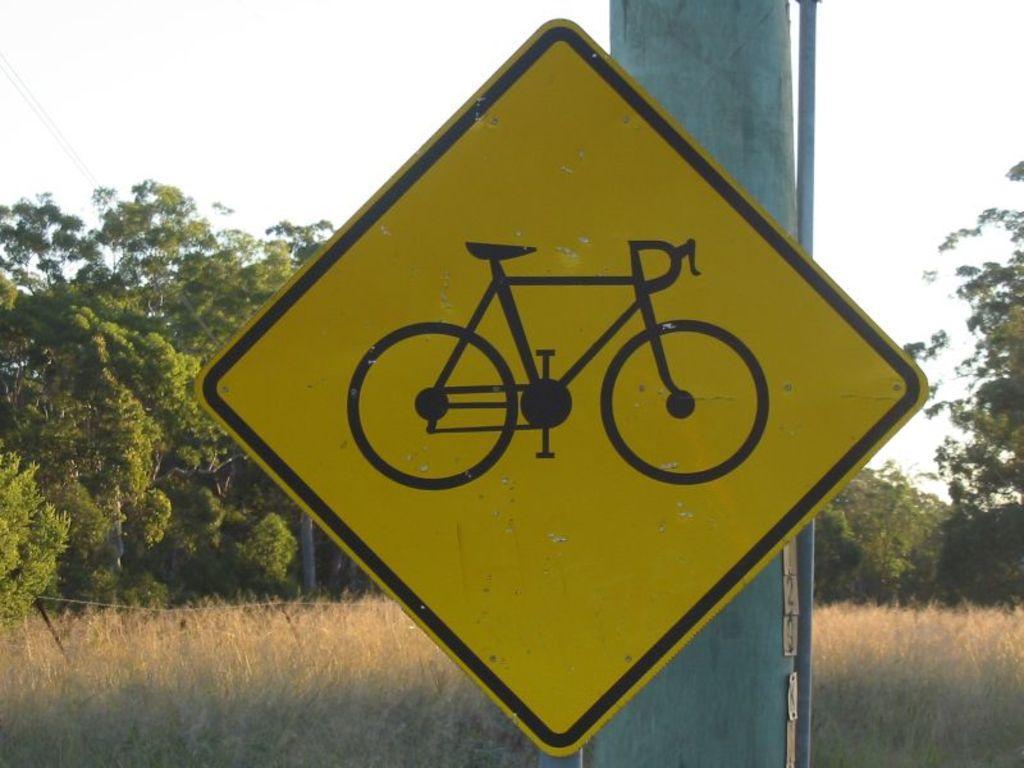Describe this image in one or two sentences. It is a sign board on the pole, on the left side there are trees. At the top it is the sky. 